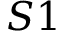<formula> <loc_0><loc_0><loc_500><loc_500>S 1</formula> 